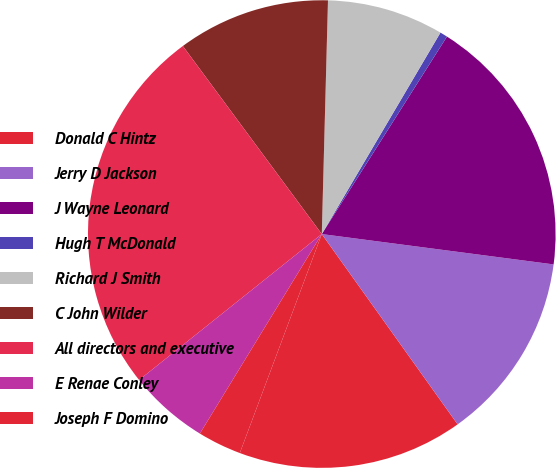Convert chart to OTSL. <chart><loc_0><loc_0><loc_500><loc_500><pie_chart><fcel>Donald C Hintz<fcel>Jerry D Jackson<fcel>J Wayne Leonard<fcel>Hugh T McDonald<fcel>Richard J Smith<fcel>C John Wilder<fcel>All directors and executive<fcel>E Renae Conley<fcel>Joseph F Domino<nl><fcel>15.57%<fcel>13.06%<fcel>18.08%<fcel>0.52%<fcel>8.05%<fcel>10.55%<fcel>25.6%<fcel>5.54%<fcel>3.03%<nl></chart> 